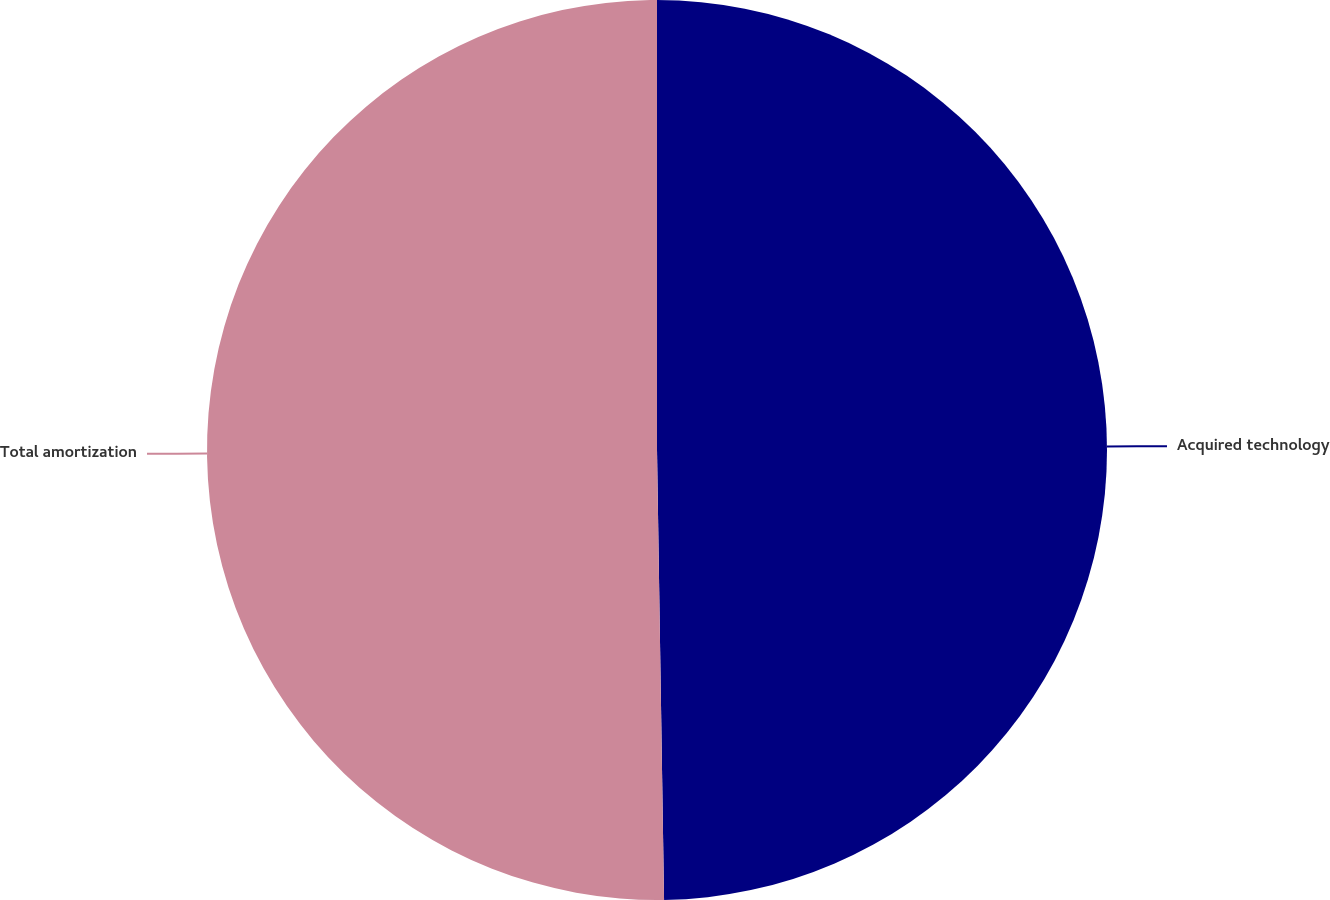<chart> <loc_0><loc_0><loc_500><loc_500><pie_chart><fcel>Acquired technology<fcel>Total amortization<nl><fcel>49.75%<fcel>50.25%<nl></chart> 